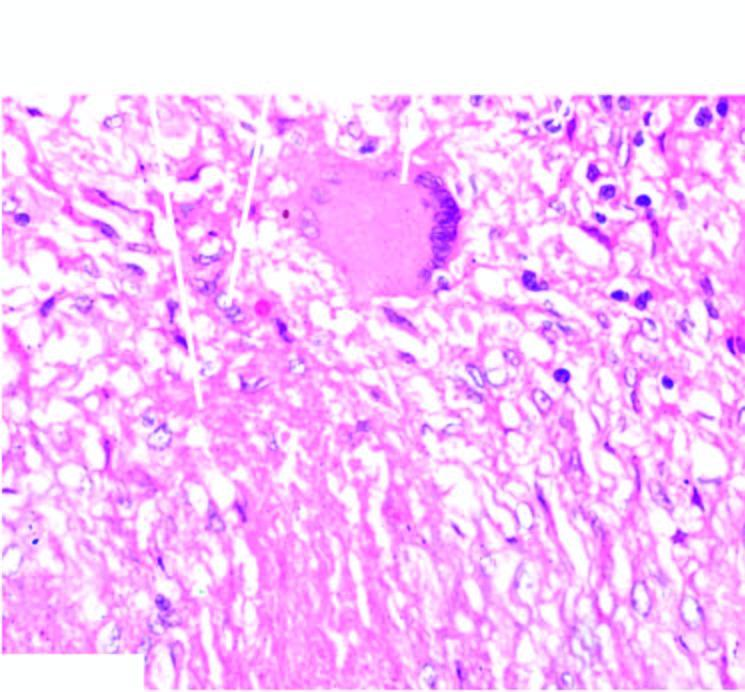does periphery show lymphocytes?
Answer the question using a single word or phrase. Yes 